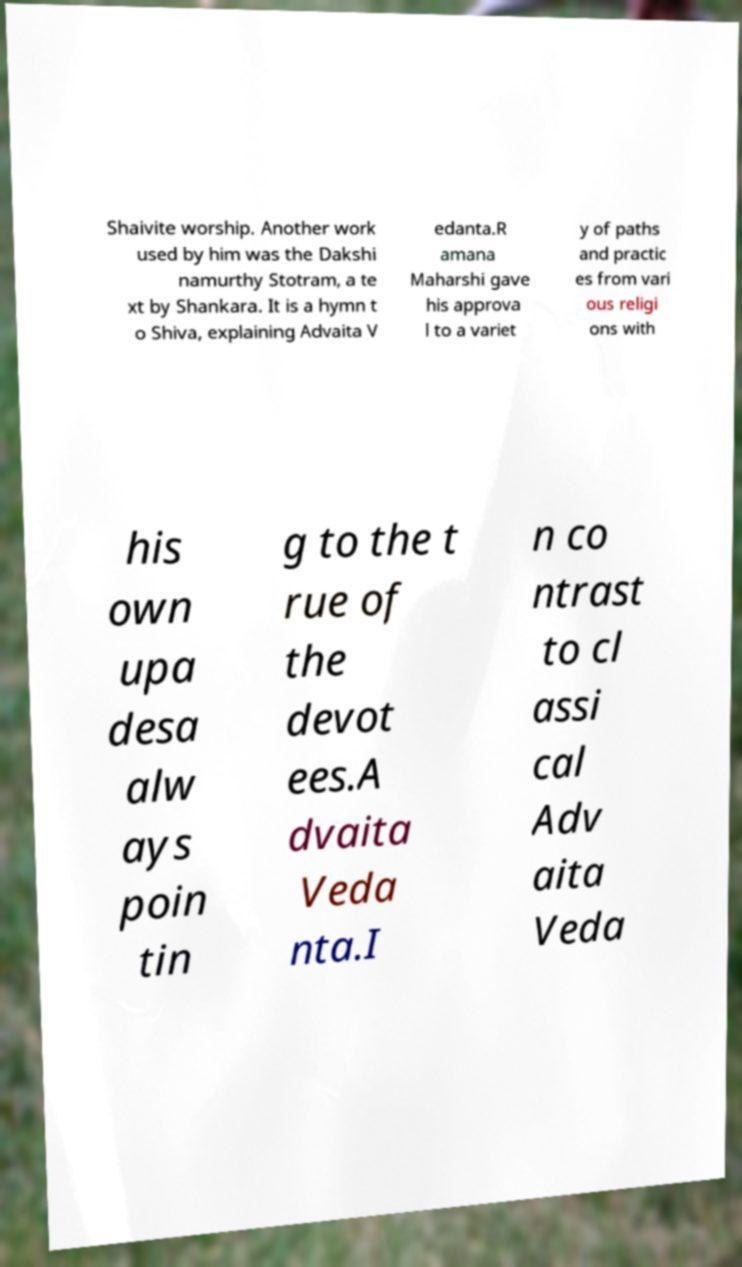For documentation purposes, I need the text within this image transcribed. Could you provide that? Shaivite worship. Another work used by him was the Dakshi namurthy Stotram, a te xt by Shankara. It is a hymn t o Shiva, explaining Advaita V edanta.R amana Maharshi gave his approva l to a variet y of paths and practic es from vari ous religi ons with his own upa desa alw ays poin tin g to the t rue of the devot ees.A dvaita Veda nta.I n co ntrast to cl assi cal Adv aita Veda 